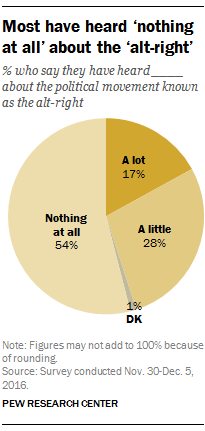Indicate a few pertinent items in this graphic. According to the survey, 17% of respondents report having heard a lot about the political movement known as the alt-right. The ratio of the "Nothing at all segment" to the "A little segment" is approximately 1.92857... 